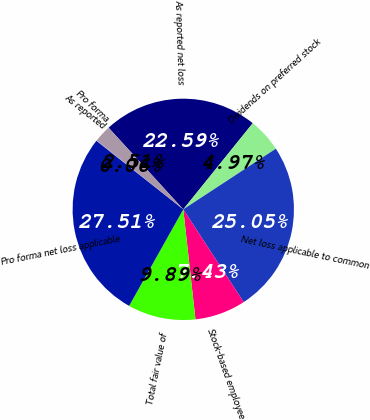<chart> <loc_0><loc_0><loc_500><loc_500><pie_chart><fcel>As reported net loss<fcel>Dividends on preferred stock<fcel>Net loss applicable to common<fcel>Stock-based employee<fcel>Total fair value of<fcel>Pro forma net loss applicable<fcel>As reported<fcel>Pro forma<nl><fcel>22.59%<fcel>4.97%<fcel>25.05%<fcel>7.43%<fcel>9.89%<fcel>27.51%<fcel>0.06%<fcel>2.51%<nl></chart> 